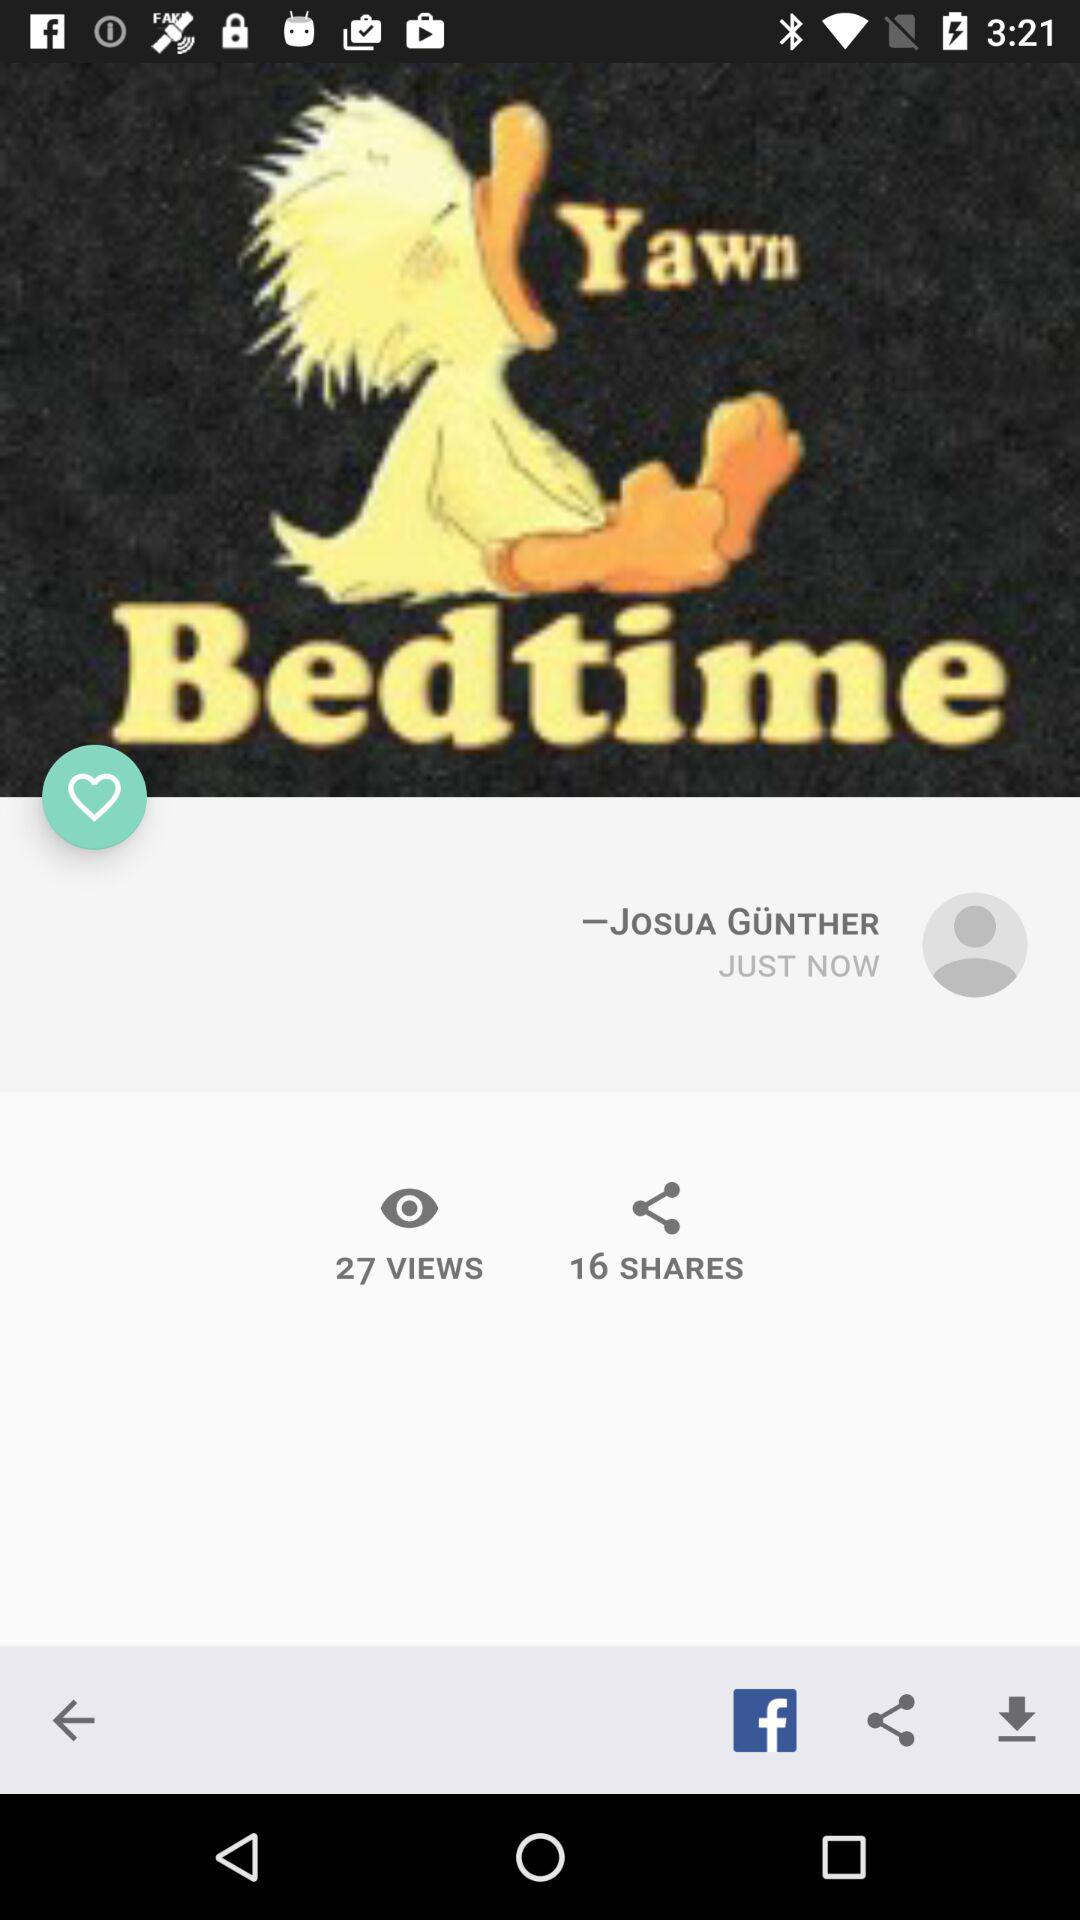How many views are there? There are 27 views. 